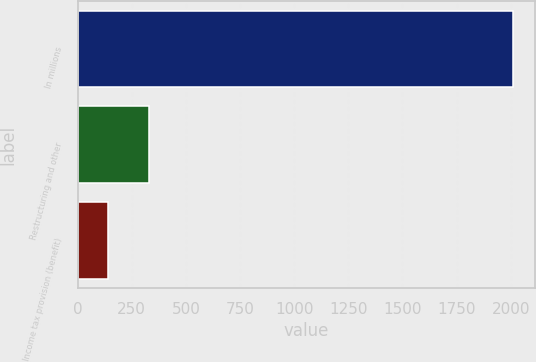Convert chart. <chart><loc_0><loc_0><loc_500><loc_500><bar_chart><fcel>In millions<fcel>Restructuring and other<fcel>Income tax provision (benefit)<nl><fcel>2010<fcel>329.7<fcel>143<nl></chart> 